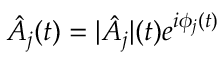Convert formula to latex. <formula><loc_0><loc_0><loc_500><loc_500>\hat { A _ { j } } ( t ) = | \hat { A _ { j } } | ( t ) e ^ { i \phi _ { j } ( t ) }</formula> 